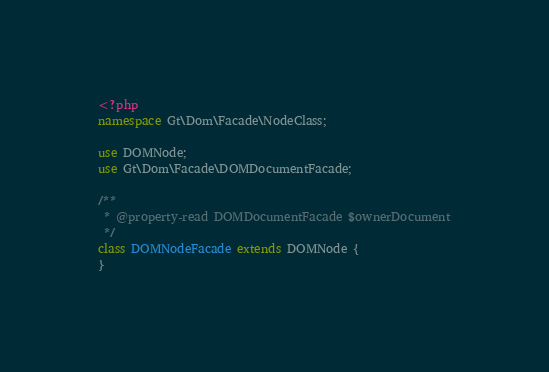<code> <loc_0><loc_0><loc_500><loc_500><_PHP_><?php
namespace Gt\Dom\Facade\NodeClass;

use DOMNode;
use Gt\Dom\Facade\DOMDocumentFacade;

/**
 * @property-read DOMDocumentFacade $ownerDocument
 */
class DOMNodeFacade extends DOMNode {
}
</code> 